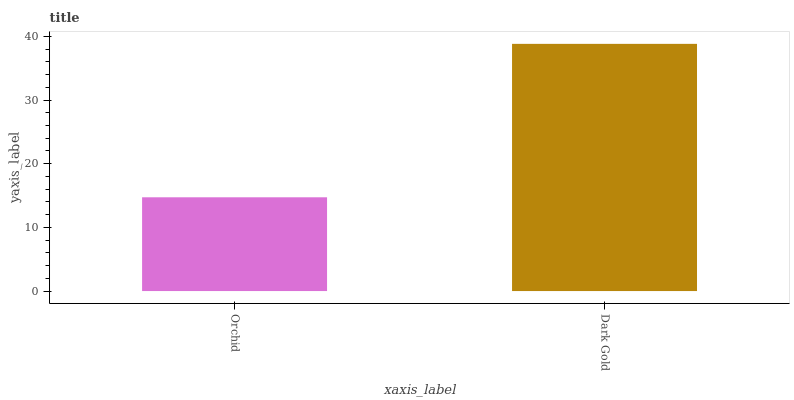Is Orchid the minimum?
Answer yes or no. Yes. Is Dark Gold the maximum?
Answer yes or no. Yes. Is Dark Gold the minimum?
Answer yes or no. No. Is Dark Gold greater than Orchid?
Answer yes or no. Yes. Is Orchid less than Dark Gold?
Answer yes or no. Yes. Is Orchid greater than Dark Gold?
Answer yes or no. No. Is Dark Gold less than Orchid?
Answer yes or no. No. Is Dark Gold the high median?
Answer yes or no. Yes. Is Orchid the low median?
Answer yes or no. Yes. Is Orchid the high median?
Answer yes or no. No. Is Dark Gold the low median?
Answer yes or no. No. 